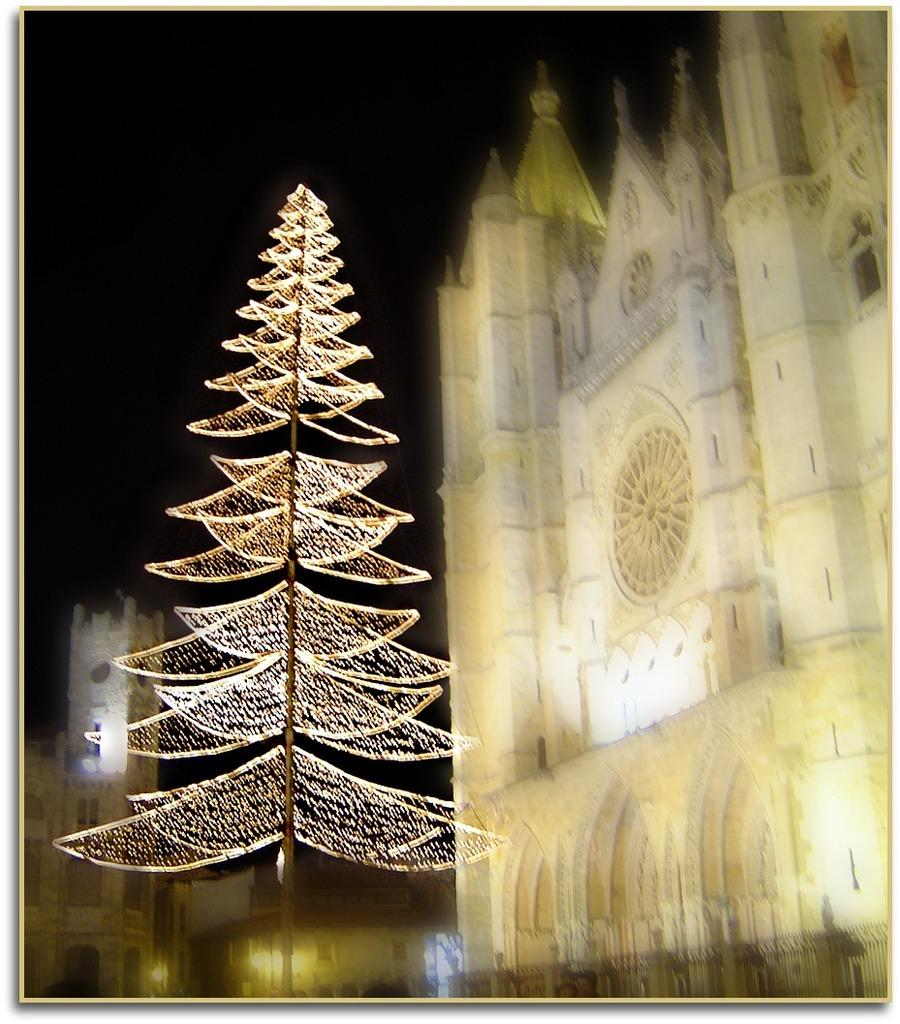What is the predominant color of the buildings in the image? The buildings in the image are white in color. Can you describe any other structures in the image besides the buildings? Yes, there is a tree-like structure in the image. What type of noise can be heard coming from the tree-like structure in the image? There is no indication of any noise in the image, as it is a still image and does not contain any audible elements. 